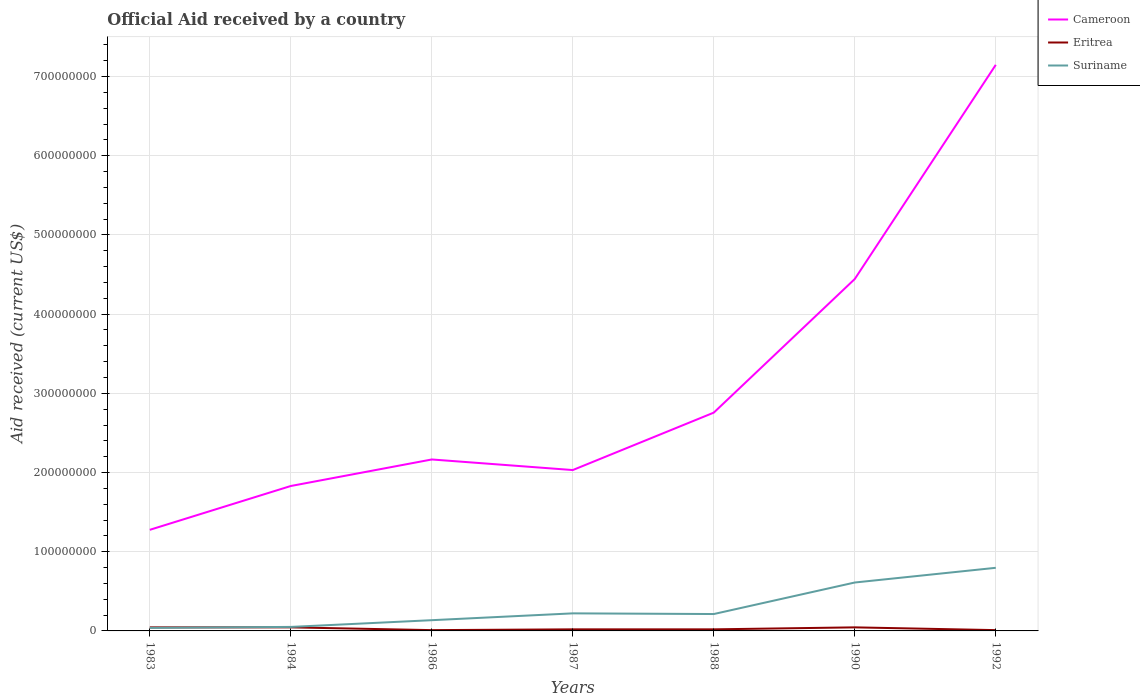Does the line corresponding to Cameroon intersect with the line corresponding to Suriname?
Keep it short and to the point. No. Is the number of lines equal to the number of legend labels?
Provide a short and direct response. Yes. Across all years, what is the maximum net official aid received in Cameroon?
Keep it short and to the point. 1.28e+08. In which year was the net official aid received in Eritrea maximum?
Give a very brief answer. 1986. What is the total net official aid received in Suriname in the graph?
Make the answer very short. 8.50e+05. What is the difference between the highest and the second highest net official aid received in Cameroon?
Your answer should be very brief. 5.87e+08. What is the difference between the highest and the lowest net official aid received in Suriname?
Make the answer very short. 2. Is the net official aid received in Eritrea strictly greater than the net official aid received in Suriname over the years?
Keep it short and to the point. No. How many lines are there?
Offer a very short reply. 3. How many years are there in the graph?
Provide a succinct answer. 7. What is the difference between two consecutive major ticks on the Y-axis?
Your answer should be very brief. 1.00e+08. Does the graph contain grids?
Your response must be concise. Yes. What is the title of the graph?
Keep it short and to the point. Official Aid received by a country. Does "Argentina" appear as one of the legend labels in the graph?
Your response must be concise. No. What is the label or title of the X-axis?
Provide a short and direct response. Years. What is the label or title of the Y-axis?
Offer a very short reply. Aid received (current US$). What is the Aid received (current US$) of Cameroon in 1983?
Make the answer very short. 1.28e+08. What is the Aid received (current US$) of Eritrea in 1983?
Keep it short and to the point. 4.50e+06. What is the Aid received (current US$) in Suriname in 1983?
Provide a short and direct response. 3.82e+06. What is the Aid received (current US$) in Cameroon in 1984?
Ensure brevity in your answer.  1.83e+08. What is the Aid received (current US$) of Eritrea in 1984?
Your response must be concise. 4.50e+06. What is the Aid received (current US$) of Suriname in 1984?
Provide a short and direct response. 5.06e+06. What is the Aid received (current US$) of Cameroon in 1986?
Ensure brevity in your answer.  2.16e+08. What is the Aid received (current US$) of Suriname in 1986?
Make the answer very short. 1.36e+07. What is the Aid received (current US$) in Cameroon in 1987?
Offer a very short reply. 2.03e+08. What is the Aid received (current US$) in Suriname in 1987?
Offer a terse response. 2.22e+07. What is the Aid received (current US$) in Cameroon in 1988?
Provide a short and direct response. 2.76e+08. What is the Aid received (current US$) of Suriname in 1988?
Your answer should be compact. 2.13e+07. What is the Aid received (current US$) in Cameroon in 1990?
Ensure brevity in your answer.  4.44e+08. What is the Aid received (current US$) of Eritrea in 1990?
Your answer should be compact. 4.50e+06. What is the Aid received (current US$) of Suriname in 1990?
Keep it short and to the point. 6.11e+07. What is the Aid received (current US$) of Cameroon in 1992?
Provide a succinct answer. 7.15e+08. What is the Aid received (current US$) in Suriname in 1992?
Make the answer very short. 7.97e+07. Across all years, what is the maximum Aid received (current US$) of Cameroon?
Your answer should be compact. 7.15e+08. Across all years, what is the maximum Aid received (current US$) in Eritrea?
Offer a terse response. 4.50e+06. Across all years, what is the maximum Aid received (current US$) in Suriname?
Your answer should be very brief. 7.97e+07. Across all years, what is the minimum Aid received (current US$) in Cameroon?
Ensure brevity in your answer.  1.28e+08. Across all years, what is the minimum Aid received (current US$) of Eritrea?
Offer a very short reply. 1.00e+06. Across all years, what is the minimum Aid received (current US$) in Suriname?
Ensure brevity in your answer.  3.82e+06. What is the total Aid received (current US$) of Cameroon in the graph?
Give a very brief answer. 2.17e+09. What is the total Aid received (current US$) in Eritrea in the graph?
Give a very brief answer. 1.95e+07. What is the total Aid received (current US$) of Suriname in the graph?
Make the answer very short. 2.07e+08. What is the difference between the Aid received (current US$) in Cameroon in 1983 and that in 1984?
Provide a succinct answer. -5.53e+07. What is the difference between the Aid received (current US$) in Eritrea in 1983 and that in 1984?
Give a very brief answer. 0. What is the difference between the Aid received (current US$) in Suriname in 1983 and that in 1984?
Your response must be concise. -1.24e+06. What is the difference between the Aid received (current US$) in Cameroon in 1983 and that in 1986?
Ensure brevity in your answer.  -8.88e+07. What is the difference between the Aid received (current US$) of Eritrea in 1983 and that in 1986?
Provide a succinct answer. 3.50e+06. What is the difference between the Aid received (current US$) of Suriname in 1983 and that in 1986?
Ensure brevity in your answer.  -9.73e+06. What is the difference between the Aid received (current US$) of Cameroon in 1983 and that in 1987?
Provide a short and direct response. -7.55e+07. What is the difference between the Aid received (current US$) of Eritrea in 1983 and that in 1987?
Offer a terse response. 2.50e+06. What is the difference between the Aid received (current US$) of Suriname in 1983 and that in 1987?
Offer a very short reply. -1.84e+07. What is the difference between the Aid received (current US$) in Cameroon in 1983 and that in 1988?
Your response must be concise. -1.48e+08. What is the difference between the Aid received (current US$) of Eritrea in 1983 and that in 1988?
Provide a short and direct response. 2.50e+06. What is the difference between the Aid received (current US$) in Suriname in 1983 and that in 1988?
Provide a short and direct response. -1.75e+07. What is the difference between the Aid received (current US$) in Cameroon in 1983 and that in 1990?
Offer a terse response. -3.17e+08. What is the difference between the Aid received (current US$) of Eritrea in 1983 and that in 1990?
Offer a very short reply. 0. What is the difference between the Aid received (current US$) in Suriname in 1983 and that in 1990?
Give a very brief answer. -5.73e+07. What is the difference between the Aid received (current US$) of Cameroon in 1983 and that in 1992?
Make the answer very short. -5.87e+08. What is the difference between the Aid received (current US$) in Eritrea in 1983 and that in 1992?
Your response must be concise. 3.50e+06. What is the difference between the Aid received (current US$) in Suriname in 1983 and that in 1992?
Provide a short and direct response. -7.59e+07. What is the difference between the Aid received (current US$) of Cameroon in 1984 and that in 1986?
Offer a terse response. -3.35e+07. What is the difference between the Aid received (current US$) in Eritrea in 1984 and that in 1986?
Give a very brief answer. 3.50e+06. What is the difference between the Aid received (current US$) of Suriname in 1984 and that in 1986?
Your response must be concise. -8.49e+06. What is the difference between the Aid received (current US$) in Cameroon in 1984 and that in 1987?
Your answer should be compact. -2.01e+07. What is the difference between the Aid received (current US$) in Eritrea in 1984 and that in 1987?
Provide a succinct answer. 2.50e+06. What is the difference between the Aid received (current US$) in Suriname in 1984 and that in 1987?
Offer a terse response. -1.71e+07. What is the difference between the Aid received (current US$) in Cameroon in 1984 and that in 1988?
Offer a very short reply. -9.26e+07. What is the difference between the Aid received (current US$) of Eritrea in 1984 and that in 1988?
Offer a terse response. 2.50e+06. What is the difference between the Aid received (current US$) of Suriname in 1984 and that in 1988?
Make the answer very short. -1.63e+07. What is the difference between the Aid received (current US$) in Cameroon in 1984 and that in 1990?
Offer a terse response. -2.61e+08. What is the difference between the Aid received (current US$) of Eritrea in 1984 and that in 1990?
Offer a terse response. 0. What is the difference between the Aid received (current US$) in Suriname in 1984 and that in 1990?
Provide a succinct answer. -5.61e+07. What is the difference between the Aid received (current US$) in Cameroon in 1984 and that in 1992?
Keep it short and to the point. -5.32e+08. What is the difference between the Aid received (current US$) in Eritrea in 1984 and that in 1992?
Keep it short and to the point. 3.50e+06. What is the difference between the Aid received (current US$) of Suriname in 1984 and that in 1992?
Keep it short and to the point. -7.46e+07. What is the difference between the Aid received (current US$) in Cameroon in 1986 and that in 1987?
Your response must be concise. 1.34e+07. What is the difference between the Aid received (current US$) of Suriname in 1986 and that in 1987?
Your response must be concise. -8.62e+06. What is the difference between the Aid received (current US$) in Cameroon in 1986 and that in 1988?
Give a very brief answer. -5.91e+07. What is the difference between the Aid received (current US$) in Eritrea in 1986 and that in 1988?
Offer a very short reply. -1.00e+06. What is the difference between the Aid received (current US$) of Suriname in 1986 and that in 1988?
Keep it short and to the point. -7.77e+06. What is the difference between the Aid received (current US$) of Cameroon in 1986 and that in 1990?
Your answer should be very brief. -2.28e+08. What is the difference between the Aid received (current US$) of Eritrea in 1986 and that in 1990?
Provide a succinct answer. -3.50e+06. What is the difference between the Aid received (current US$) of Suriname in 1986 and that in 1990?
Ensure brevity in your answer.  -4.76e+07. What is the difference between the Aid received (current US$) of Cameroon in 1986 and that in 1992?
Provide a short and direct response. -4.98e+08. What is the difference between the Aid received (current US$) in Suriname in 1986 and that in 1992?
Provide a succinct answer. -6.62e+07. What is the difference between the Aid received (current US$) in Cameroon in 1987 and that in 1988?
Provide a succinct answer. -7.25e+07. What is the difference between the Aid received (current US$) of Suriname in 1987 and that in 1988?
Give a very brief answer. 8.50e+05. What is the difference between the Aid received (current US$) of Cameroon in 1987 and that in 1990?
Your answer should be very brief. -2.41e+08. What is the difference between the Aid received (current US$) in Eritrea in 1987 and that in 1990?
Your answer should be compact. -2.50e+06. What is the difference between the Aid received (current US$) of Suriname in 1987 and that in 1990?
Offer a very short reply. -3.90e+07. What is the difference between the Aid received (current US$) of Cameroon in 1987 and that in 1992?
Your answer should be compact. -5.12e+08. What is the difference between the Aid received (current US$) in Eritrea in 1987 and that in 1992?
Offer a very short reply. 1.00e+06. What is the difference between the Aid received (current US$) of Suriname in 1987 and that in 1992?
Give a very brief answer. -5.75e+07. What is the difference between the Aid received (current US$) in Cameroon in 1988 and that in 1990?
Provide a succinct answer. -1.69e+08. What is the difference between the Aid received (current US$) in Eritrea in 1988 and that in 1990?
Provide a short and direct response. -2.50e+06. What is the difference between the Aid received (current US$) of Suriname in 1988 and that in 1990?
Your response must be concise. -3.98e+07. What is the difference between the Aid received (current US$) in Cameroon in 1988 and that in 1992?
Keep it short and to the point. -4.39e+08. What is the difference between the Aid received (current US$) of Suriname in 1988 and that in 1992?
Keep it short and to the point. -5.84e+07. What is the difference between the Aid received (current US$) in Cameroon in 1990 and that in 1992?
Provide a short and direct response. -2.70e+08. What is the difference between the Aid received (current US$) in Eritrea in 1990 and that in 1992?
Your answer should be compact. 3.50e+06. What is the difference between the Aid received (current US$) in Suriname in 1990 and that in 1992?
Provide a succinct answer. -1.86e+07. What is the difference between the Aid received (current US$) in Cameroon in 1983 and the Aid received (current US$) in Eritrea in 1984?
Make the answer very short. 1.23e+08. What is the difference between the Aid received (current US$) of Cameroon in 1983 and the Aid received (current US$) of Suriname in 1984?
Ensure brevity in your answer.  1.23e+08. What is the difference between the Aid received (current US$) in Eritrea in 1983 and the Aid received (current US$) in Suriname in 1984?
Offer a very short reply. -5.60e+05. What is the difference between the Aid received (current US$) of Cameroon in 1983 and the Aid received (current US$) of Eritrea in 1986?
Ensure brevity in your answer.  1.27e+08. What is the difference between the Aid received (current US$) in Cameroon in 1983 and the Aid received (current US$) in Suriname in 1986?
Provide a short and direct response. 1.14e+08. What is the difference between the Aid received (current US$) of Eritrea in 1983 and the Aid received (current US$) of Suriname in 1986?
Provide a short and direct response. -9.05e+06. What is the difference between the Aid received (current US$) in Cameroon in 1983 and the Aid received (current US$) in Eritrea in 1987?
Provide a short and direct response. 1.26e+08. What is the difference between the Aid received (current US$) of Cameroon in 1983 and the Aid received (current US$) of Suriname in 1987?
Offer a very short reply. 1.05e+08. What is the difference between the Aid received (current US$) in Eritrea in 1983 and the Aid received (current US$) in Suriname in 1987?
Your response must be concise. -1.77e+07. What is the difference between the Aid received (current US$) of Cameroon in 1983 and the Aid received (current US$) of Eritrea in 1988?
Make the answer very short. 1.26e+08. What is the difference between the Aid received (current US$) of Cameroon in 1983 and the Aid received (current US$) of Suriname in 1988?
Keep it short and to the point. 1.06e+08. What is the difference between the Aid received (current US$) of Eritrea in 1983 and the Aid received (current US$) of Suriname in 1988?
Ensure brevity in your answer.  -1.68e+07. What is the difference between the Aid received (current US$) of Cameroon in 1983 and the Aid received (current US$) of Eritrea in 1990?
Your response must be concise. 1.23e+08. What is the difference between the Aid received (current US$) in Cameroon in 1983 and the Aid received (current US$) in Suriname in 1990?
Make the answer very short. 6.65e+07. What is the difference between the Aid received (current US$) of Eritrea in 1983 and the Aid received (current US$) of Suriname in 1990?
Provide a short and direct response. -5.66e+07. What is the difference between the Aid received (current US$) in Cameroon in 1983 and the Aid received (current US$) in Eritrea in 1992?
Your answer should be very brief. 1.27e+08. What is the difference between the Aid received (current US$) in Cameroon in 1983 and the Aid received (current US$) in Suriname in 1992?
Offer a very short reply. 4.80e+07. What is the difference between the Aid received (current US$) of Eritrea in 1983 and the Aid received (current US$) of Suriname in 1992?
Your response must be concise. -7.52e+07. What is the difference between the Aid received (current US$) of Cameroon in 1984 and the Aid received (current US$) of Eritrea in 1986?
Provide a succinct answer. 1.82e+08. What is the difference between the Aid received (current US$) in Cameroon in 1984 and the Aid received (current US$) in Suriname in 1986?
Your answer should be compact. 1.69e+08. What is the difference between the Aid received (current US$) in Eritrea in 1984 and the Aid received (current US$) in Suriname in 1986?
Ensure brevity in your answer.  -9.05e+06. What is the difference between the Aid received (current US$) of Cameroon in 1984 and the Aid received (current US$) of Eritrea in 1987?
Provide a short and direct response. 1.81e+08. What is the difference between the Aid received (current US$) in Cameroon in 1984 and the Aid received (current US$) in Suriname in 1987?
Your answer should be very brief. 1.61e+08. What is the difference between the Aid received (current US$) of Eritrea in 1984 and the Aid received (current US$) of Suriname in 1987?
Your response must be concise. -1.77e+07. What is the difference between the Aid received (current US$) in Cameroon in 1984 and the Aid received (current US$) in Eritrea in 1988?
Provide a succinct answer. 1.81e+08. What is the difference between the Aid received (current US$) in Cameroon in 1984 and the Aid received (current US$) in Suriname in 1988?
Provide a short and direct response. 1.62e+08. What is the difference between the Aid received (current US$) of Eritrea in 1984 and the Aid received (current US$) of Suriname in 1988?
Make the answer very short. -1.68e+07. What is the difference between the Aid received (current US$) of Cameroon in 1984 and the Aid received (current US$) of Eritrea in 1990?
Keep it short and to the point. 1.78e+08. What is the difference between the Aid received (current US$) in Cameroon in 1984 and the Aid received (current US$) in Suriname in 1990?
Your answer should be very brief. 1.22e+08. What is the difference between the Aid received (current US$) in Eritrea in 1984 and the Aid received (current US$) in Suriname in 1990?
Your answer should be very brief. -5.66e+07. What is the difference between the Aid received (current US$) of Cameroon in 1984 and the Aid received (current US$) of Eritrea in 1992?
Keep it short and to the point. 1.82e+08. What is the difference between the Aid received (current US$) in Cameroon in 1984 and the Aid received (current US$) in Suriname in 1992?
Give a very brief answer. 1.03e+08. What is the difference between the Aid received (current US$) of Eritrea in 1984 and the Aid received (current US$) of Suriname in 1992?
Your answer should be very brief. -7.52e+07. What is the difference between the Aid received (current US$) of Cameroon in 1986 and the Aid received (current US$) of Eritrea in 1987?
Make the answer very short. 2.14e+08. What is the difference between the Aid received (current US$) of Cameroon in 1986 and the Aid received (current US$) of Suriname in 1987?
Offer a terse response. 1.94e+08. What is the difference between the Aid received (current US$) in Eritrea in 1986 and the Aid received (current US$) in Suriname in 1987?
Your response must be concise. -2.12e+07. What is the difference between the Aid received (current US$) of Cameroon in 1986 and the Aid received (current US$) of Eritrea in 1988?
Your answer should be compact. 2.14e+08. What is the difference between the Aid received (current US$) of Cameroon in 1986 and the Aid received (current US$) of Suriname in 1988?
Ensure brevity in your answer.  1.95e+08. What is the difference between the Aid received (current US$) in Eritrea in 1986 and the Aid received (current US$) in Suriname in 1988?
Your response must be concise. -2.03e+07. What is the difference between the Aid received (current US$) in Cameroon in 1986 and the Aid received (current US$) in Eritrea in 1990?
Provide a succinct answer. 2.12e+08. What is the difference between the Aid received (current US$) of Cameroon in 1986 and the Aid received (current US$) of Suriname in 1990?
Make the answer very short. 1.55e+08. What is the difference between the Aid received (current US$) of Eritrea in 1986 and the Aid received (current US$) of Suriname in 1990?
Give a very brief answer. -6.01e+07. What is the difference between the Aid received (current US$) of Cameroon in 1986 and the Aid received (current US$) of Eritrea in 1992?
Ensure brevity in your answer.  2.15e+08. What is the difference between the Aid received (current US$) of Cameroon in 1986 and the Aid received (current US$) of Suriname in 1992?
Offer a terse response. 1.37e+08. What is the difference between the Aid received (current US$) in Eritrea in 1986 and the Aid received (current US$) in Suriname in 1992?
Ensure brevity in your answer.  -7.87e+07. What is the difference between the Aid received (current US$) of Cameroon in 1987 and the Aid received (current US$) of Eritrea in 1988?
Make the answer very short. 2.01e+08. What is the difference between the Aid received (current US$) of Cameroon in 1987 and the Aid received (current US$) of Suriname in 1988?
Ensure brevity in your answer.  1.82e+08. What is the difference between the Aid received (current US$) of Eritrea in 1987 and the Aid received (current US$) of Suriname in 1988?
Offer a terse response. -1.93e+07. What is the difference between the Aid received (current US$) in Cameroon in 1987 and the Aid received (current US$) in Eritrea in 1990?
Ensure brevity in your answer.  1.99e+08. What is the difference between the Aid received (current US$) of Cameroon in 1987 and the Aid received (current US$) of Suriname in 1990?
Your answer should be very brief. 1.42e+08. What is the difference between the Aid received (current US$) in Eritrea in 1987 and the Aid received (current US$) in Suriname in 1990?
Give a very brief answer. -5.91e+07. What is the difference between the Aid received (current US$) in Cameroon in 1987 and the Aid received (current US$) in Eritrea in 1992?
Ensure brevity in your answer.  2.02e+08. What is the difference between the Aid received (current US$) of Cameroon in 1987 and the Aid received (current US$) of Suriname in 1992?
Offer a very short reply. 1.23e+08. What is the difference between the Aid received (current US$) of Eritrea in 1987 and the Aid received (current US$) of Suriname in 1992?
Make the answer very short. -7.77e+07. What is the difference between the Aid received (current US$) in Cameroon in 1988 and the Aid received (current US$) in Eritrea in 1990?
Your response must be concise. 2.71e+08. What is the difference between the Aid received (current US$) of Cameroon in 1988 and the Aid received (current US$) of Suriname in 1990?
Provide a short and direct response. 2.14e+08. What is the difference between the Aid received (current US$) of Eritrea in 1988 and the Aid received (current US$) of Suriname in 1990?
Your response must be concise. -5.91e+07. What is the difference between the Aid received (current US$) of Cameroon in 1988 and the Aid received (current US$) of Eritrea in 1992?
Keep it short and to the point. 2.75e+08. What is the difference between the Aid received (current US$) in Cameroon in 1988 and the Aid received (current US$) in Suriname in 1992?
Your answer should be compact. 1.96e+08. What is the difference between the Aid received (current US$) in Eritrea in 1988 and the Aid received (current US$) in Suriname in 1992?
Provide a short and direct response. -7.77e+07. What is the difference between the Aid received (current US$) of Cameroon in 1990 and the Aid received (current US$) of Eritrea in 1992?
Make the answer very short. 4.43e+08. What is the difference between the Aid received (current US$) of Cameroon in 1990 and the Aid received (current US$) of Suriname in 1992?
Provide a short and direct response. 3.65e+08. What is the difference between the Aid received (current US$) in Eritrea in 1990 and the Aid received (current US$) in Suriname in 1992?
Your answer should be very brief. -7.52e+07. What is the average Aid received (current US$) in Cameroon per year?
Offer a very short reply. 3.09e+08. What is the average Aid received (current US$) in Eritrea per year?
Your response must be concise. 2.79e+06. What is the average Aid received (current US$) of Suriname per year?
Your answer should be very brief. 2.95e+07. In the year 1983, what is the difference between the Aid received (current US$) in Cameroon and Aid received (current US$) in Eritrea?
Your response must be concise. 1.23e+08. In the year 1983, what is the difference between the Aid received (current US$) in Cameroon and Aid received (current US$) in Suriname?
Offer a terse response. 1.24e+08. In the year 1983, what is the difference between the Aid received (current US$) of Eritrea and Aid received (current US$) of Suriname?
Your response must be concise. 6.80e+05. In the year 1984, what is the difference between the Aid received (current US$) of Cameroon and Aid received (current US$) of Eritrea?
Your response must be concise. 1.78e+08. In the year 1984, what is the difference between the Aid received (current US$) in Cameroon and Aid received (current US$) in Suriname?
Offer a terse response. 1.78e+08. In the year 1984, what is the difference between the Aid received (current US$) in Eritrea and Aid received (current US$) in Suriname?
Provide a succinct answer. -5.60e+05. In the year 1986, what is the difference between the Aid received (current US$) in Cameroon and Aid received (current US$) in Eritrea?
Provide a short and direct response. 2.15e+08. In the year 1986, what is the difference between the Aid received (current US$) of Cameroon and Aid received (current US$) of Suriname?
Offer a terse response. 2.03e+08. In the year 1986, what is the difference between the Aid received (current US$) of Eritrea and Aid received (current US$) of Suriname?
Your answer should be very brief. -1.26e+07. In the year 1987, what is the difference between the Aid received (current US$) of Cameroon and Aid received (current US$) of Eritrea?
Ensure brevity in your answer.  2.01e+08. In the year 1987, what is the difference between the Aid received (current US$) of Cameroon and Aid received (current US$) of Suriname?
Your answer should be compact. 1.81e+08. In the year 1987, what is the difference between the Aid received (current US$) of Eritrea and Aid received (current US$) of Suriname?
Your answer should be compact. -2.02e+07. In the year 1988, what is the difference between the Aid received (current US$) in Cameroon and Aid received (current US$) in Eritrea?
Your answer should be compact. 2.74e+08. In the year 1988, what is the difference between the Aid received (current US$) of Cameroon and Aid received (current US$) of Suriname?
Make the answer very short. 2.54e+08. In the year 1988, what is the difference between the Aid received (current US$) in Eritrea and Aid received (current US$) in Suriname?
Offer a very short reply. -1.93e+07. In the year 1990, what is the difference between the Aid received (current US$) in Cameroon and Aid received (current US$) in Eritrea?
Your answer should be compact. 4.40e+08. In the year 1990, what is the difference between the Aid received (current US$) of Cameroon and Aid received (current US$) of Suriname?
Offer a very short reply. 3.83e+08. In the year 1990, what is the difference between the Aid received (current US$) in Eritrea and Aid received (current US$) in Suriname?
Give a very brief answer. -5.66e+07. In the year 1992, what is the difference between the Aid received (current US$) in Cameroon and Aid received (current US$) in Eritrea?
Ensure brevity in your answer.  7.14e+08. In the year 1992, what is the difference between the Aid received (current US$) of Cameroon and Aid received (current US$) of Suriname?
Offer a terse response. 6.35e+08. In the year 1992, what is the difference between the Aid received (current US$) of Eritrea and Aid received (current US$) of Suriname?
Ensure brevity in your answer.  -7.87e+07. What is the ratio of the Aid received (current US$) of Cameroon in 1983 to that in 1984?
Offer a terse response. 0.7. What is the ratio of the Aid received (current US$) in Suriname in 1983 to that in 1984?
Provide a short and direct response. 0.75. What is the ratio of the Aid received (current US$) in Cameroon in 1983 to that in 1986?
Provide a short and direct response. 0.59. What is the ratio of the Aid received (current US$) of Eritrea in 1983 to that in 1986?
Offer a very short reply. 4.5. What is the ratio of the Aid received (current US$) of Suriname in 1983 to that in 1986?
Your response must be concise. 0.28. What is the ratio of the Aid received (current US$) in Cameroon in 1983 to that in 1987?
Offer a terse response. 0.63. What is the ratio of the Aid received (current US$) in Eritrea in 1983 to that in 1987?
Make the answer very short. 2.25. What is the ratio of the Aid received (current US$) of Suriname in 1983 to that in 1987?
Keep it short and to the point. 0.17. What is the ratio of the Aid received (current US$) of Cameroon in 1983 to that in 1988?
Make the answer very short. 0.46. What is the ratio of the Aid received (current US$) in Eritrea in 1983 to that in 1988?
Ensure brevity in your answer.  2.25. What is the ratio of the Aid received (current US$) of Suriname in 1983 to that in 1988?
Offer a very short reply. 0.18. What is the ratio of the Aid received (current US$) in Cameroon in 1983 to that in 1990?
Your answer should be very brief. 0.29. What is the ratio of the Aid received (current US$) of Eritrea in 1983 to that in 1990?
Provide a succinct answer. 1. What is the ratio of the Aid received (current US$) in Suriname in 1983 to that in 1990?
Provide a succinct answer. 0.06. What is the ratio of the Aid received (current US$) in Cameroon in 1983 to that in 1992?
Ensure brevity in your answer.  0.18. What is the ratio of the Aid received (current US$) of Suriname in 1983 to that in 1992?
Your answer should be very brief. 0.05. What is the ratio of the Aid received (current US$) in Cameroon in 1984 to that in 1986?
Ensure brevity in your answer.  0.85. What is the ratio of the Aid received (current US$) of Suriname in 1984 to that in 1986?
Your response must be concise. 0.37. What is the ratio of the Aid received (current US$) of Cameroon in 1984 to that in 1987?
Offer a very short reply. 0.9. What is the ratio of the Aid received (current US$) in Eritrea in 1984 to that in 1987?
Your answer should be very brief. 2.25. What is the ratio of the Aid received (current US$) in Suriname in 1984 to that in 1987?
Your response must be concise. 0.23. What is the ratio of the Aid received (current US$) in Cameroon in 1984 to that in 1988?
Your response must be concise. 0.66. What is the ratio of the Aid received (current US$) of Eritrea in 1984 to that in 1988?
Keep it short and to the point. 2.25. What is the ratio of the Aid received (current US$) of Suriname in 1984 to that in 1988?
Your answer should be very brief. 0.24. What is the ratio of the Aid received (current US$) in Cameroon in 1984 to that in 1990?
Keep it short and to the point. 0.41. What is the ratio of the Aid received (current US$) of Eritrea in 1984 to that in 1990?
Provide a short and direct response. 1. What is the ratio of the Aid received (current US$) of Suriname in 1984 to that in 1990?
Your answer should be very brief. 0.08. What is the ratio of the Aid received (current US$) of Cameroon in 1984 to that in 1992?
Offer a very short reply. 0.26. What is the ratio of the Aid received (current US$) in Suriname in 1984 to that in 1992?
Provide a succinct answer. 0.06. What is the ratio of the Aid received (current US$) in Cameroon in 1986 to that in 1987?
Ensure brevity in your answer.  1.07. What is the ratio of the Aid received (current US$) in Eritrea in 1986 to that in 1987?
Provide a succinct answer. 0.5. What is the ratio of the Aid received (current US$) in Suriname in 1986 to that in 1987?
Your response must be concise. 0.61. What is the ratio of the Aid received (current US$) in Cameroon in 1986 to that in 1988?
Offer a very short reply. 0.79. What is the ratio of the Aid received (current US$) in Suriname in 1986 to that in 1988?
Give a very brief answer. 0.64. What is the ratio of the Aid received (current US$) of Cameroon in 1986 to that in 1990?
Provide a succinct answer. 0.49. What is the ratio of the Aid received (current US$) of Eritrea in 1986 to that in 1990?
Give a very brief answer. 0.22. What is the ratio of the Aid received (current US$) in Suriname in 1986 to that in 1990?
Offer a terse response. 0.22. What is the ratio of the Aid received (current US$) of Cameroon in 1986 to that in 1992?
Your answer should be compact. 0.3. What is the ratio of the Aid received (current US$) in Eritrea in 1986 to that in 1992?
Provide a succinct answer. 1. What is the ratio of the Aid received (current US$) of Suriname in 1986 to that in 1992?
Offer a terse response. 0.17. What is the ratio of the Aid received (current US$) of Cameroon in 1987 to that in 1988?
Provide a short and direct response. 0.74. What is the ratio of the Aid received (current US$) of Suriname in 1987 to that in 1988?
Offer a very short reply. 1.04. What is the ratio of the Aid received (current US$) in Cameroon in 1987 to that in 1990?
Provide a short and direct response. 0.46. What is the ratio of the Aid received (current US$) in Eritrea in 1987 to that in 1990?
Keep it short and to the point. 0.44. What is the ratio of the Aid received (current US$) of Suriname in 1987 to that in 1990?
Provide a short and direct response. 0.36. What is the ratio of the Aid received (current US$) of Cameroon in 1987 to that in 1992?
Your answer should be compact. 0.28. What is the ratio of the Aid received (current US$) of Suriname in 1987 to that in 1992?
Provide a succinct answer. 0.28. What is the ratio of the Aid received (current US$) in Cameroon in 1988 to that in 1990?
Offer a very short reply. 0.62. What is the ratio of the Aid received (current US$) of Eritrea in 1988 to that in 1990?
Provide a succinct answer. 0.44. What is the ratio of the Aid received (current US$) in Suriname in 1988 to that in 1990?
Offer a very short reply. 0.35. What is the ratio of the Aid received (current US$) of Cameroon in 1988 to that in 1992?
Provide a succinct answer. 0.39. What is the ratio of the Aid received (current US$) of Suriname in 1988 to that in 1992?
Provide a short and direct response. 0.27. What is the ratio of the Aid received (current US$) in Cameroon in 1990 to that in 1992?
Keep it short and to the point. 0.62. What is the ratio of the Aid received (current US$) of Eritrea in 1990 to that in 1992?
Offer a terse response. 4.5. What is the ratio of the Aid received (current US$) in Suriname in 1990 to that in 1992?
Offer a terse response. 0.77. What is the difference between the highest and the second highest Aid received (current US$) of Cameroon?
Your answer should be very brief. 2.70e+08. What is the difference between the highest and the second highest Aid received (current US$) in Suriname?
Make the answer very short. 1.86e+07. What is the difference between the highest and the lowest Aid received (current US$) in Cameroon?
Give a very brief answer. 5.87e+08. What is the difference between the highest and the lowest Aid received (current US$) of Eritrea?
Offer a terse response. 3.50e+06. What is the difference between the highest and the lowest Aid received (current US$) in Suriname?
Your response must be concise. 7.59e+07. 